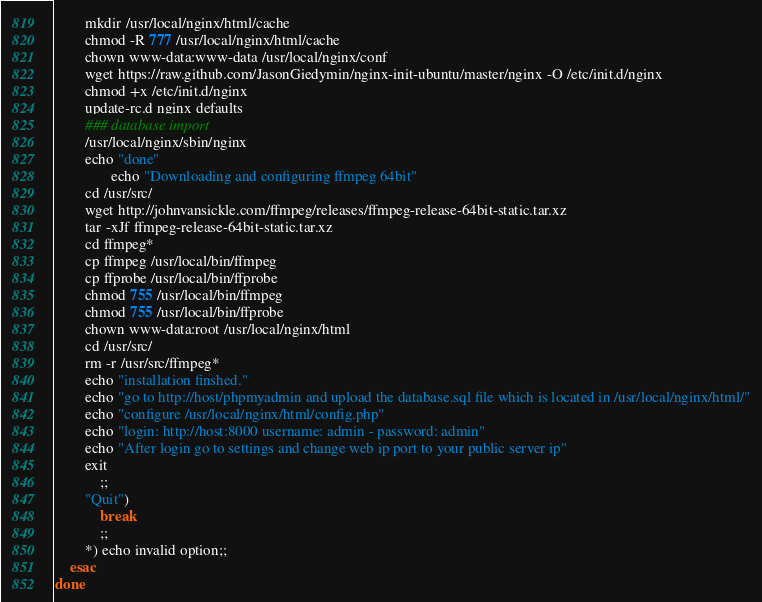Convert code to text. <code><loc_0><loc_0><loc_500><loc_500><_Bash_>		mkdir /usr/local/nginx/html/cache
		chmod -R 777 /usr/local/nginx/html/cache
		chown www-data:www-data /usr/local/nginx/conf
		wget https://raw.github.com/JasonGiedymin/nginx-init-ubuntu/master/nginx -O /etc/init.d/nginx
        chmod +x /etc/init.d/nginx
        update-rc.d nginx defaults
		### database import
		/usr/local/nginx/sbin/nginx
		echo "done"
               echo "Downloading and configuring ffmpeg 64bit"
		cd /usr/src/
		wget http://johnvansickle.com/ffmpeg/releases/ffmpeg-release-64bit-static.tar.xz
		tar -xJf ffmpeg-release-64bit-static.tar.xz
		cd ffmpeg*
		cp ffmpeg /usr/local/bin/ffmpeg
		cp ffprobe /usr/local/bin/ffprobe
		chmod 755 /usr/local/bin/ffmpeg
		chmod 755 /usr/local/bin/ffprobe
		chown www-data:root /usr/local/nginx/html
		cd /usr/src/
		rm -r /usr/src/ffmpeg*
		echo "installation finshed."
		echo "go to http://host/phpmyadmin and upload the database.sql file which is located in /usr/local/nginx/html/"
		echo "configure /usr/local/nginx/html/config.php"
		echo "login: http://host:8000 username: admin - password: admin"
		echo "After login go to settings and change web ip port to your public server ip"
		exit
            ;;
        "Quit")
            break
            ;;
        *) echo invalid option;;
    esac
done
</code> 